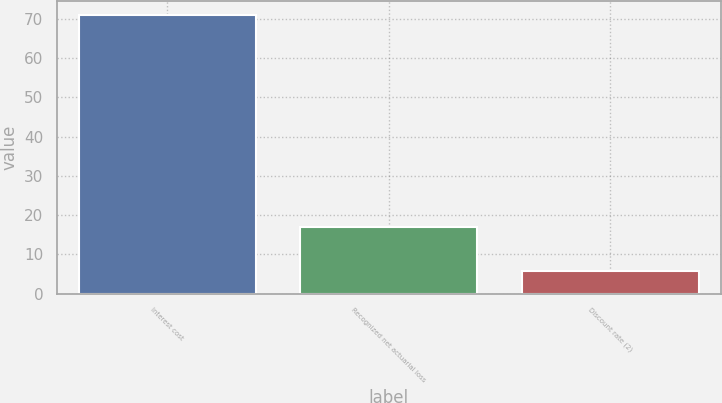Convert chart to OTSL. <chart><loc_0><loc_0><loc_500><loc_500><bar_chart><fcel>Interest cost<fcel>Recognized net actuarial loss<fcel>Discount rate (2)<nl><fcel>71<fcel>17<fcel>5.75<nl></chart> 